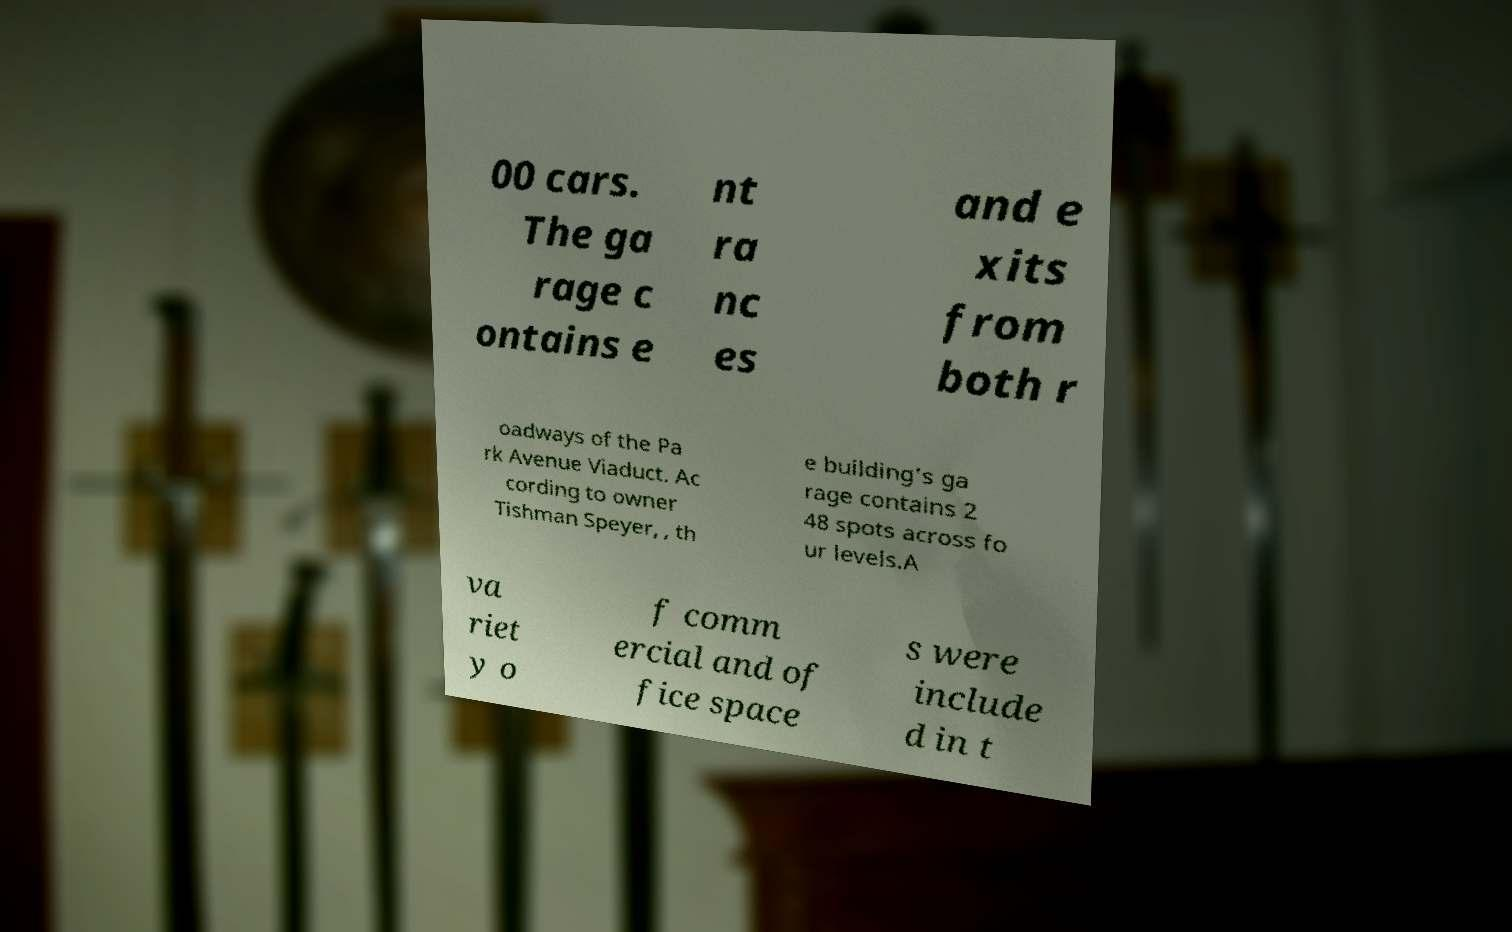There's text embedded in this image that I need extracted. Can you transcribe it verbatim? 00 cars. The ga rage c ontains e nt ra nc es and e xits from both r oadways of the Pa rk Avenue Viaduct. Ac cording to owner Tishman Speyer, , th e building's ga rage contains 2 48 spots across fo ur levels.A va riet y o f comm ercial and of fice space s were include d in t 